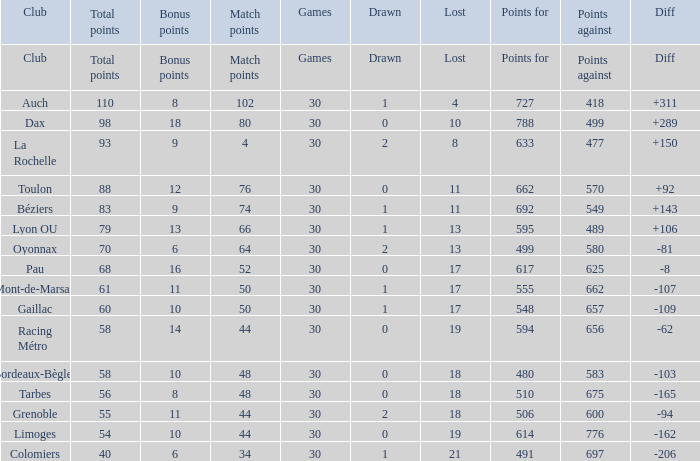What is the diff for a club that has a value of 662 for points for? 92.0. 